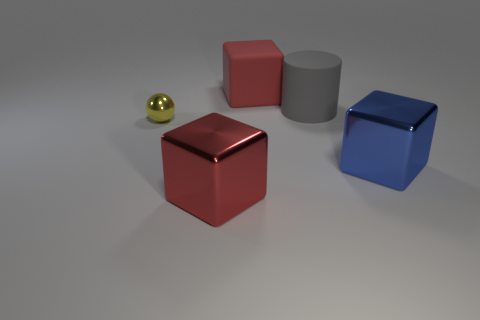Subtract all big blue shiny cubes. How many cubes are left? 2 Subtract all blue spheres. How many red cubes are left? 2 Add 4 big brown balls. How many big brown balls exist? 4 Add 1 blue rubber balls. How many objects exist? 6 Subtract all red cubes. How many cubes are left? 1 Subtract 0 blue cylinders. How many objects are left? 5 Subtract all cylinders. How many objects are left? 4 Subtract all gray cubes. Subtract all purple cylinders. How many cubes are left? 3 Subtract all large blue cubes. Subtract all big metallic cubes. How many objects are left? 2 Add 5 large rubber cylinders. How many large rubber cylinders are left? 6 